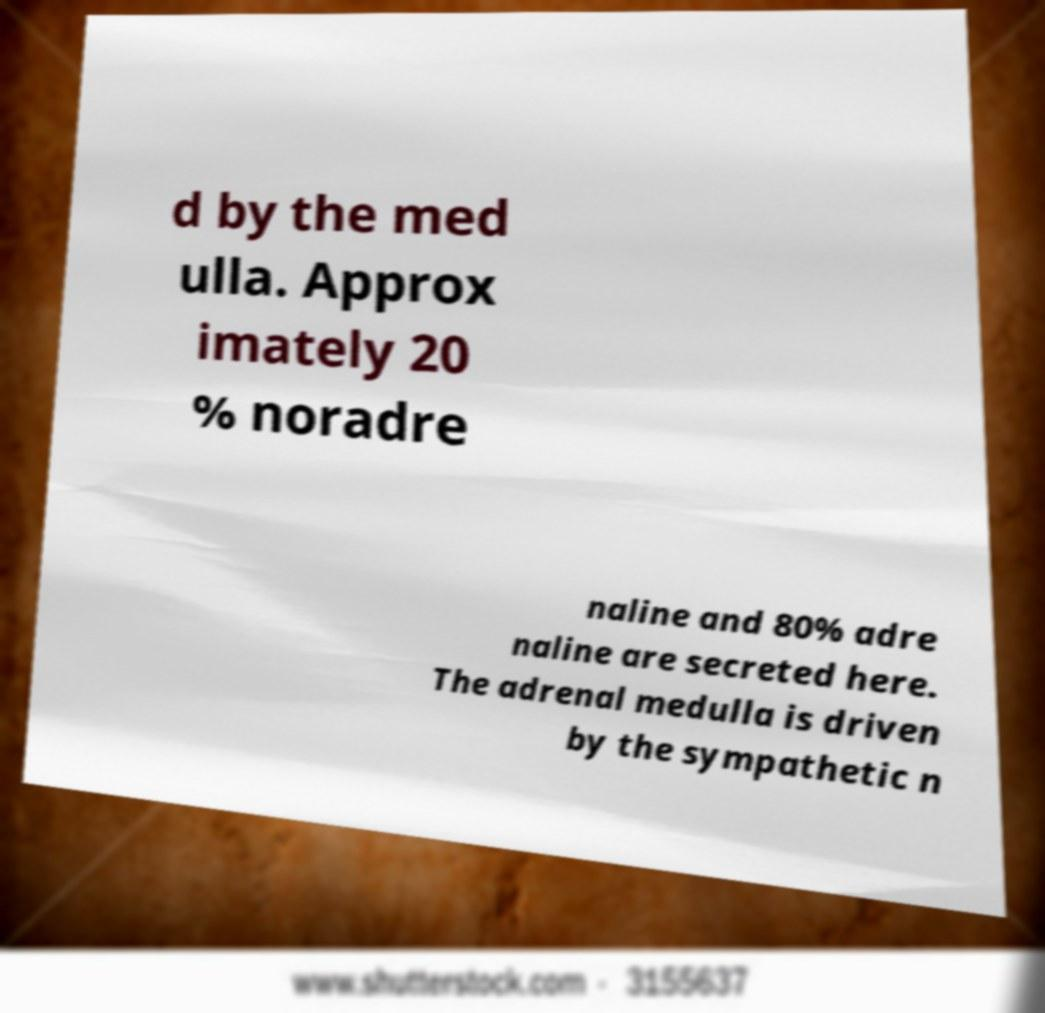Please identify and transcribe the text found in this image. d by the med ulla. Approx imately 20 % noradre naline and 80% adre naline are secreted here. The adrenal medulla is driven by the sympathetic n 